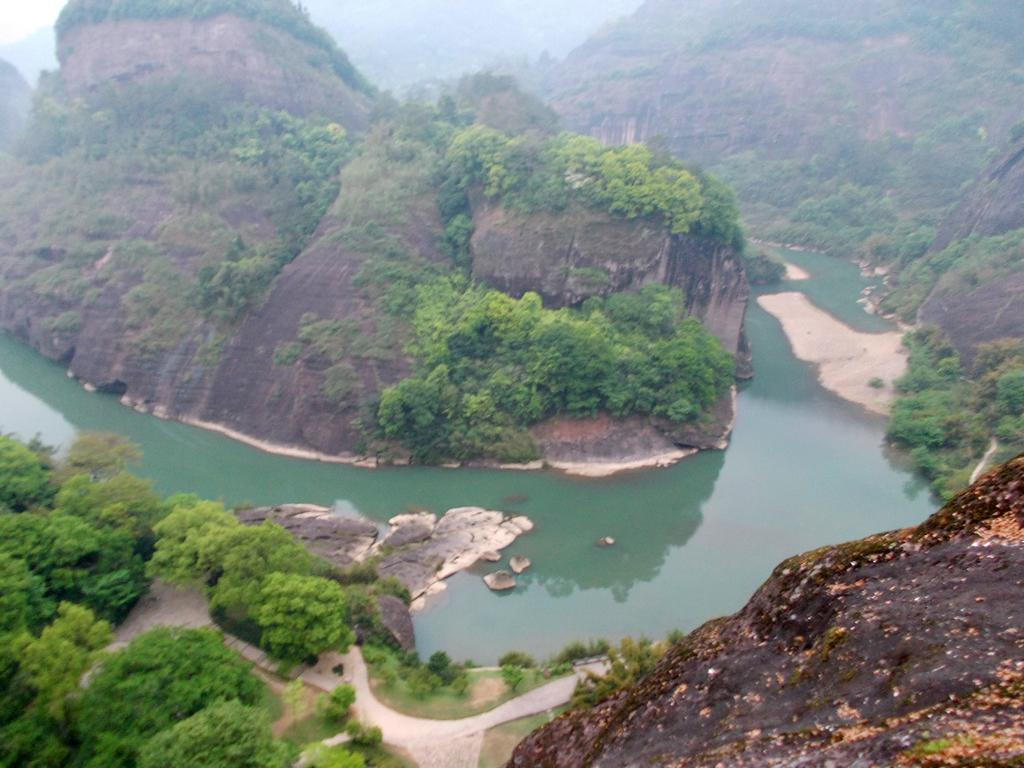What type of natural features can be seen at the bottom of the image? There are trees and mountains at the bottom of the image. What is the main feature in the center of the image? There is a river in the center of the image. What can be seen in the background of the image? There are mountains and trees in the background of the image. How does the comb affect the river in the image? There is no comb present in the image, so it cannot affect the river. Can you spot any deer in the image? There are no deer visible in the image. 